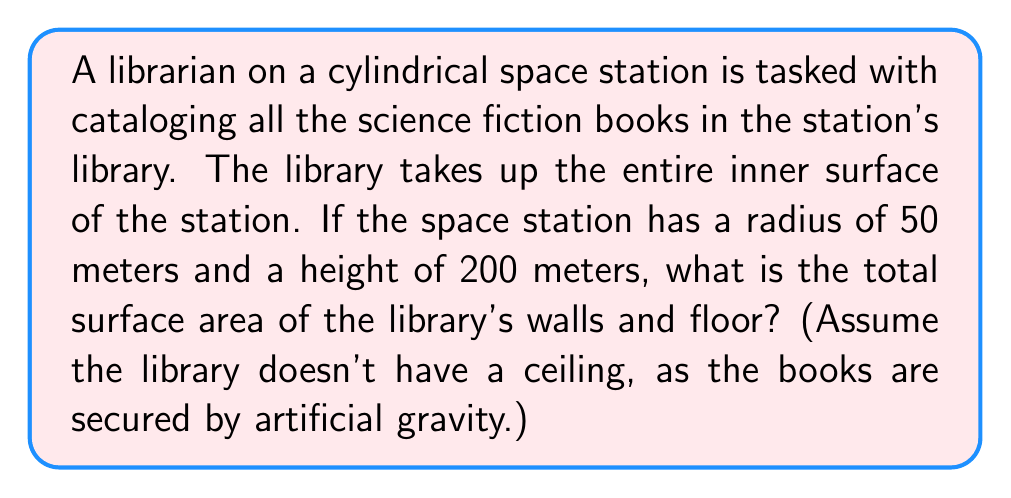Show me your answer to this math problem. To solve this problem, we need to calculate the surface area of a cylinder without its top. The surface area of a cylinder consists of two parts:

1. The lateral surface area (the curved part)
2. The circular base

Let's break it down step-by-step:

1. Calculate the lateral surface area:
   The formula for the lateral surface area of a cylinder is:
   $$A_{\text{lateral}} = 2\pi rh$$
   where $r$ is the radius and $h$ is the height.
   
   Substituting the given values:
   $$A_{\text{lateral}} = 2\pi \cdot 50 \text{ m} \cdot 200 \text{ m} = 62,831.85 \text{ m}^2$$

2. Calculate the area of the circular base:
   The formula for the area of a circle is:
   $$A_{\text{circle}} = \pi r^2$$
   
   Substituting the given radius:
   $$A_{\text{circle}} = \pi \cdot (50 \text{ m})^2 = 7,853.98 \text{ m}^2$$

3. Sum up the total surface area:
   $$A_{\text{total}} = A_{\text{lateral}} + A_{\text{circle}}$$
   $$A_{\text{total}} = 62,831.85 \text{ m}^2 + 7,853.98 \text{ m}^2 = 70,685.83 \text{ m}^2$$

[asy]
import geometry;

real r = 50;
real h = 200;
real scale = 0.5;

path p = (0,0)--(0,h)::(r,0)--(r,h);
path q = arc((0,0),r,0,180)--arc((0,h),r,180,0);
revolution a = revolution(p,q);
draw(surface(a),paleblue+opacity(0.5));
draw(p,blue);
draw(q,blue);

label("$r = 50\text{ m}$", (r/2,-10), S);
label("$h = 200\text{ m}$", (r+10,h/2), E);

draw((0,-5)--(r,-5),Arrows);
draw((-5,0)--(-5,h),Arrows);
</asy>
Answer: The total surface area of the library's walls and floor on the cylindrical space station is approximately 70,685.83 square meters. 